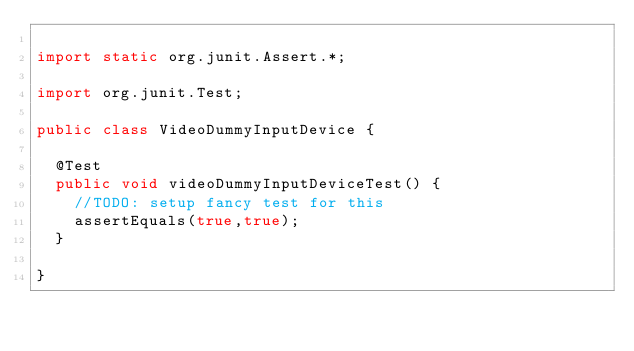<code> <loc_0><loc_0><loc_500><loc_500><_Java_>
import static org.junit.Assert.*;

import org.junit.Test;

public class VideoDummyInputDevice {

	@Test
	public void videoDummyInputDeviceTest() {
		//TODO: setup fancy test for this
		assertEquals(true,true);
	}

}
</code> 